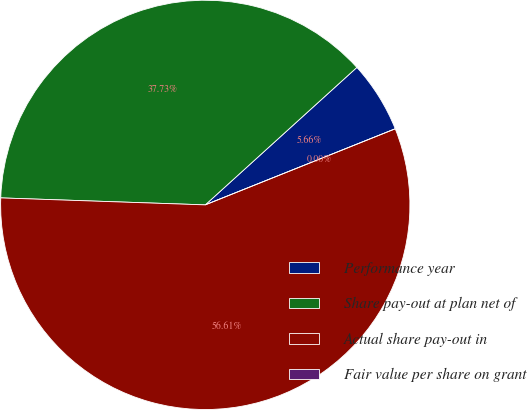Convert chart to OTSL. <chart><loc_0><loc_0><loc_500><loc_500><pie_chart><fcel>Performance year<fcel>Share pay-out at plan net of<fcel>Actual share pay-out in<fcel>Fair value per share on grant<nl><fcel>5.66%<fcel>37.73%<fcel>56.6%<fcel>0.0%<nl></chart> 